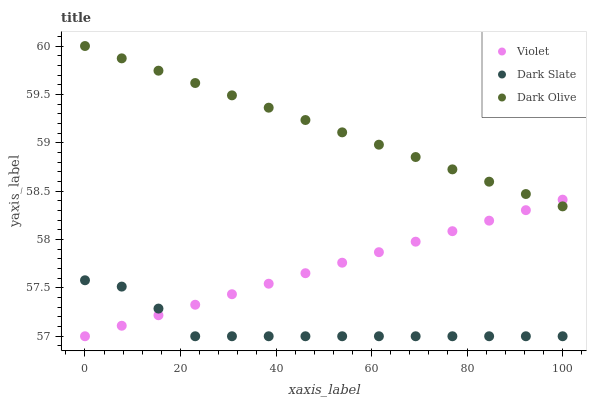Does Dark Slate have the minimum area under the curve?
Answer yes or no. Yes. Does Dark Olive have the maximum area under the curve?
Answer yes or no. Yes. Does Violet have the minimum area under the curve?
Answer yes or no. No. Does Violet have the maximum area under the curve?
Answer yes or no. No. Is Dark Olive the smoothest?
Answer yes or no. Yes. Is Dark Slate the roughest?
Answer yes or no. Yes. Is Violet the smoothest?
Answer yes or no. No. Is Violet the roughest?
Answer yes or no. No. Does Dark Slate have the lowest value?
Answer yes or no. Yes. Does Dark Olive have the lowest value?
Answer yes or no. No. Does Dark Olive have the highest value?
Answer yes or no. Yes. Does Violet have the highest value?
Answer yes or no. No. Is Dark Slate less than Dark Olive?
Answer yes or no. Yes. Is Dark Olive greater than Dark Slate?
Answer yes or no. Yes. Does Violet intersect Dark Olive?
Answer yes or no. Yes. Is Violet less than Dark Olive?
Answer yes or no. No. Is Violet greater than Dark Olive?
Answer yes or no. No. Does Dark Slate intersect Dark Olive?
Answer yes or no. No. 